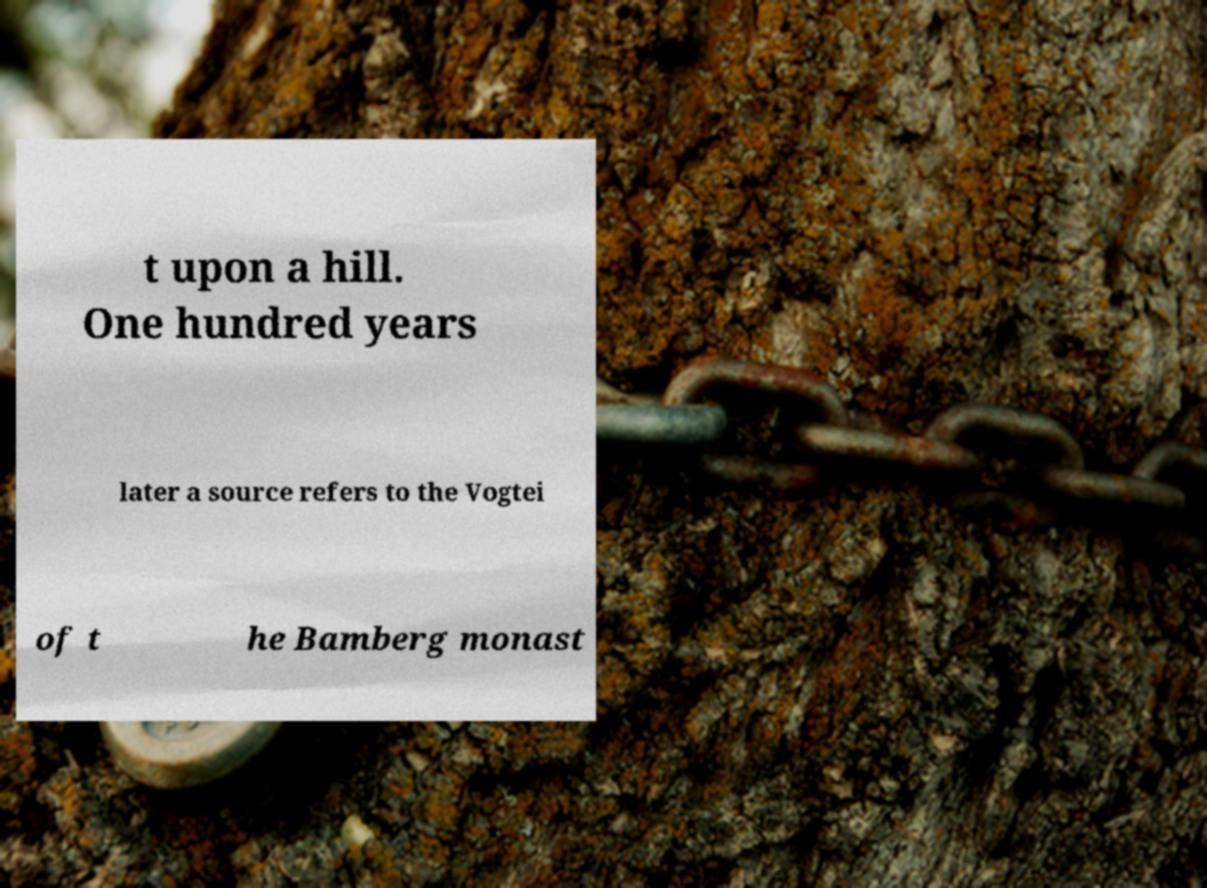I need the written content from this picture converted into text. Can you do that? t upon a hill. One hundred years later a source refers to the Vogtei of t he Bamberg monast 